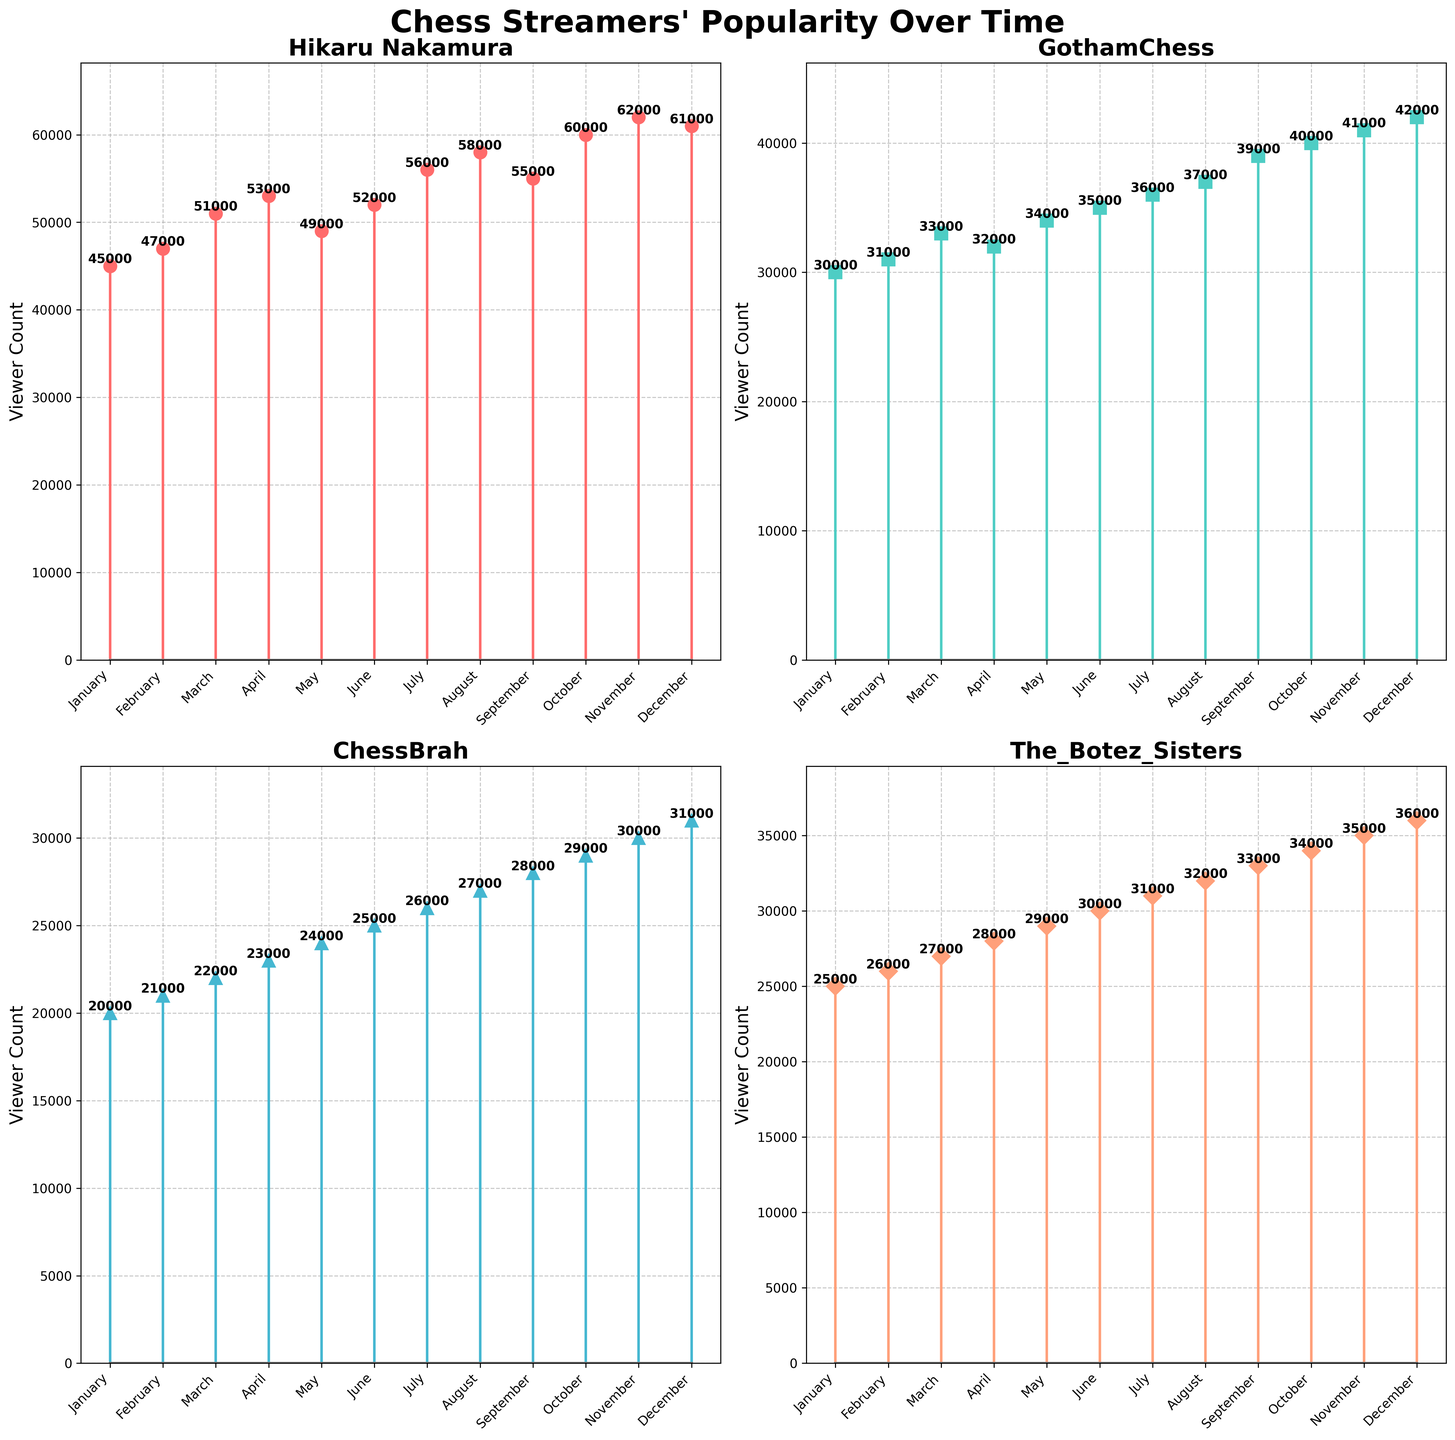What is the title of the figure? The title of the figure is displayed prominently at the top of the plot.
Answer: Chess Streamers' Popularity Over Time How many streamers are shown in the figure? The figure contains 4 subplots, each corresponding to a different streamer.
Answer: 4 Which streamer has the highest viewer count in December? By looking at the viewer counts for each streamer in December, Hikaru Nakamura has the highest value.
Answer: Hikaru Nakamura What is the viewer count for GothamChess in November? Locate the plot for GothamChess and find the data point corresponding to November.
Answer: 41000 What is the general trend for ChessBrah's viewer count throughout the year? The viewer count for ChessBrah shows a steady increase from January to December.
Answer: Increasing How does The_Botez_Sisters' viewer count in August compare to Hikaru Nakamura's viewer count in the same month? The_Botez_Sisters have around 32000 viewers in August, while Hikaru Nakamura has around 58000 viewers.
Answer: Hikaru Nakamura has more viewers What is the average viewer count for Hikaru Nakamura in the first half of the year? (January - June) Sum the viewer counts for Hikaru Nakamura from January to June and divide by 6. (45000 + 47000 + 51000 + 53000 + 49000 + 52000) / 6 = 49500
Answer: 49500 Which month shows the highest viewer count for The_Botez_Sisters? Identify the month with the highest data point in the subplot for The_Botez_Sisters.
Answer: December What is the difference in viewer count between ChessBrah and The_Botez_Sisters in July? Subtract the viewer count for ChessBrah from that of The_Botez_Sisters in July. 31000 - 26000 = 5000
Answer: 5000 Is there any month where all streamers had an increase in viewer count compared to the previous month? If yes, name one such month. By scanning through all subplots, April shows an increase in viewer count compared to March for all streamers.
Answer: April 